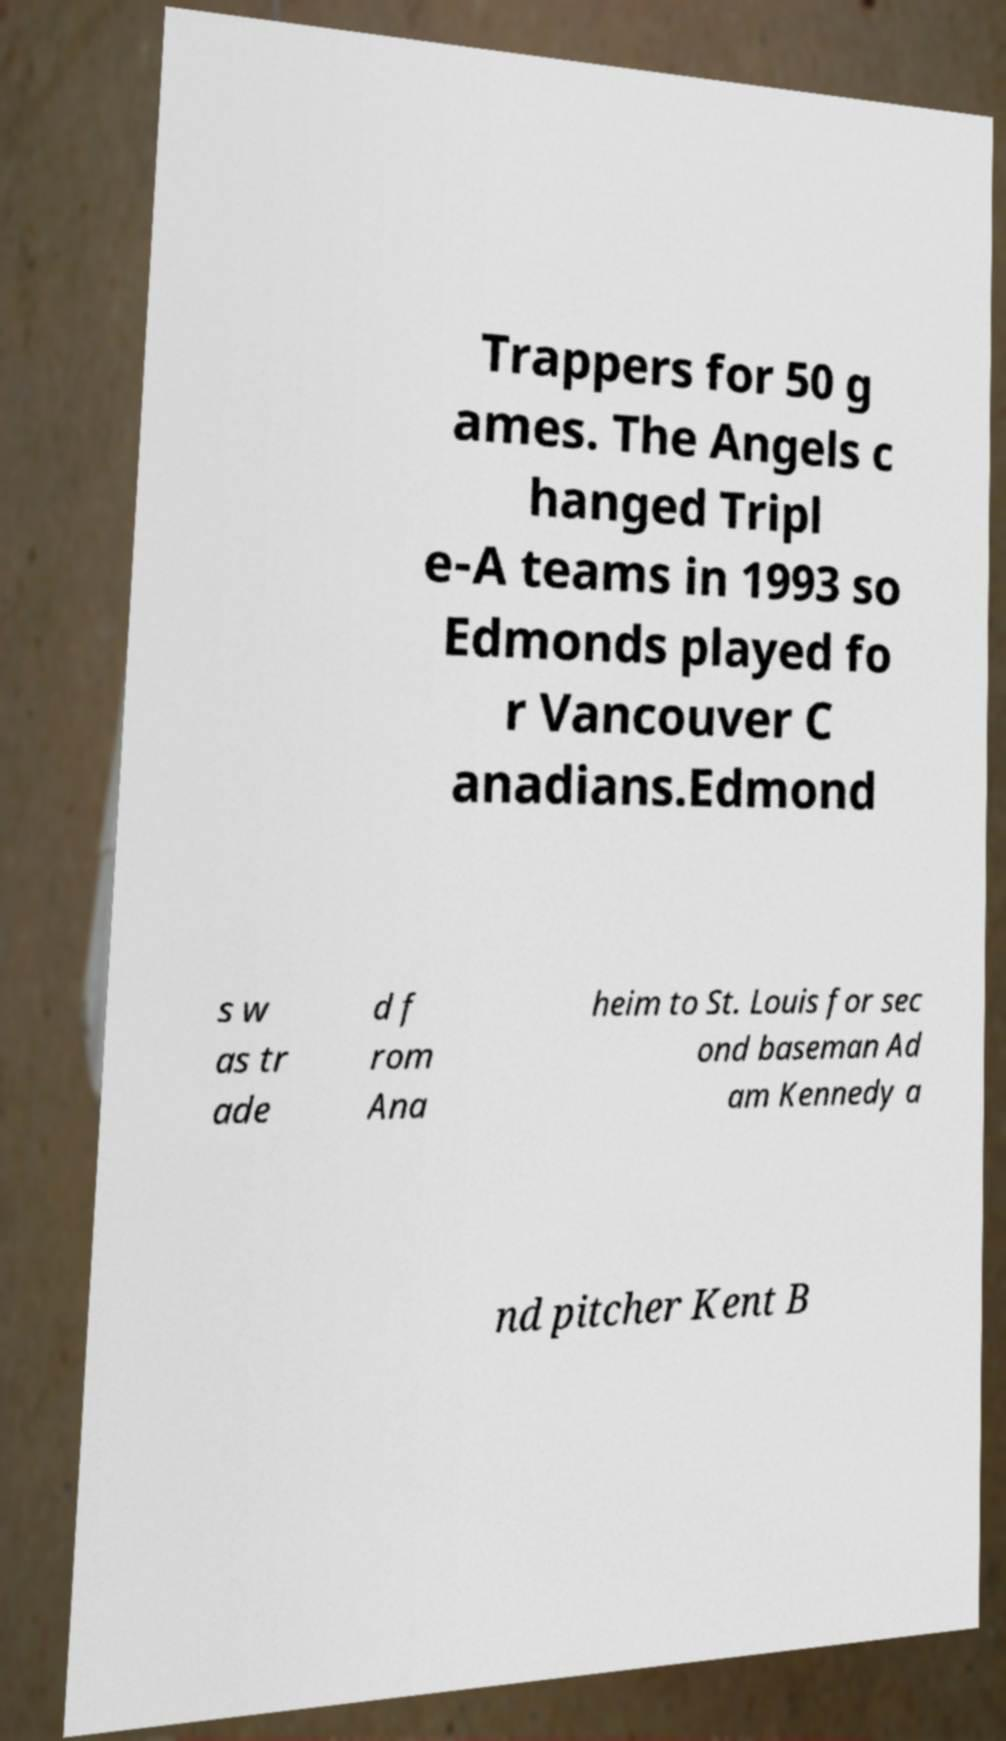Can you read and provide the text displayed in the image?This photo seems to have some interesting text. Can you extract and type it out for me? Trappers for 50 g ames. The Angels c hanged Tripl e-A teams in 1993 so Edmonds played fo r Vancouver C anadians.Edmond s w as tr ade d f rom Ana heim to St. Louis for sec ond baseman Ad am Kennedy a nd pitcher Kent B 